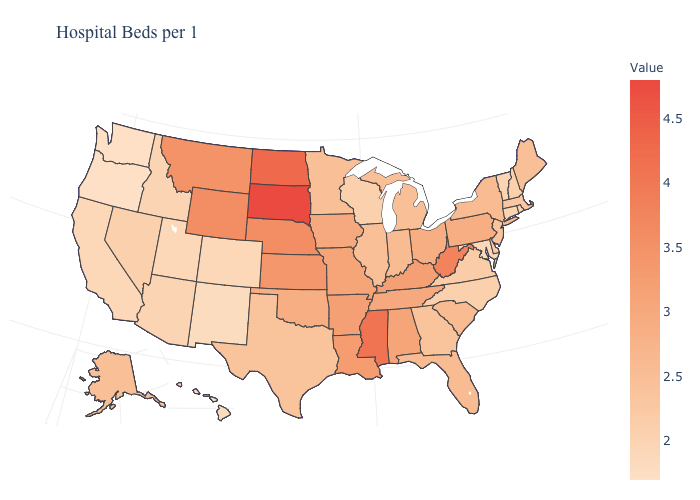Among the states that border Kansas , does Colorado have the lowest value?
Concise answer only. Yes. Does Texas have a higher value than Vermont?
Concise answer only. Yes. Is the legend a continuous bar?
Write a very short answer. Yes. Which states have the lowest value in the USA?
Be succinct. Oregon, Washington. Among the states that border Wisconsin , which have the highest value?
Short answer required. Iowa. Does Colorado have the highest value in the West?
Concise answer only. No. Among the states that border Illinois , which have the highest value?
Quick response, please. Kentucky. 